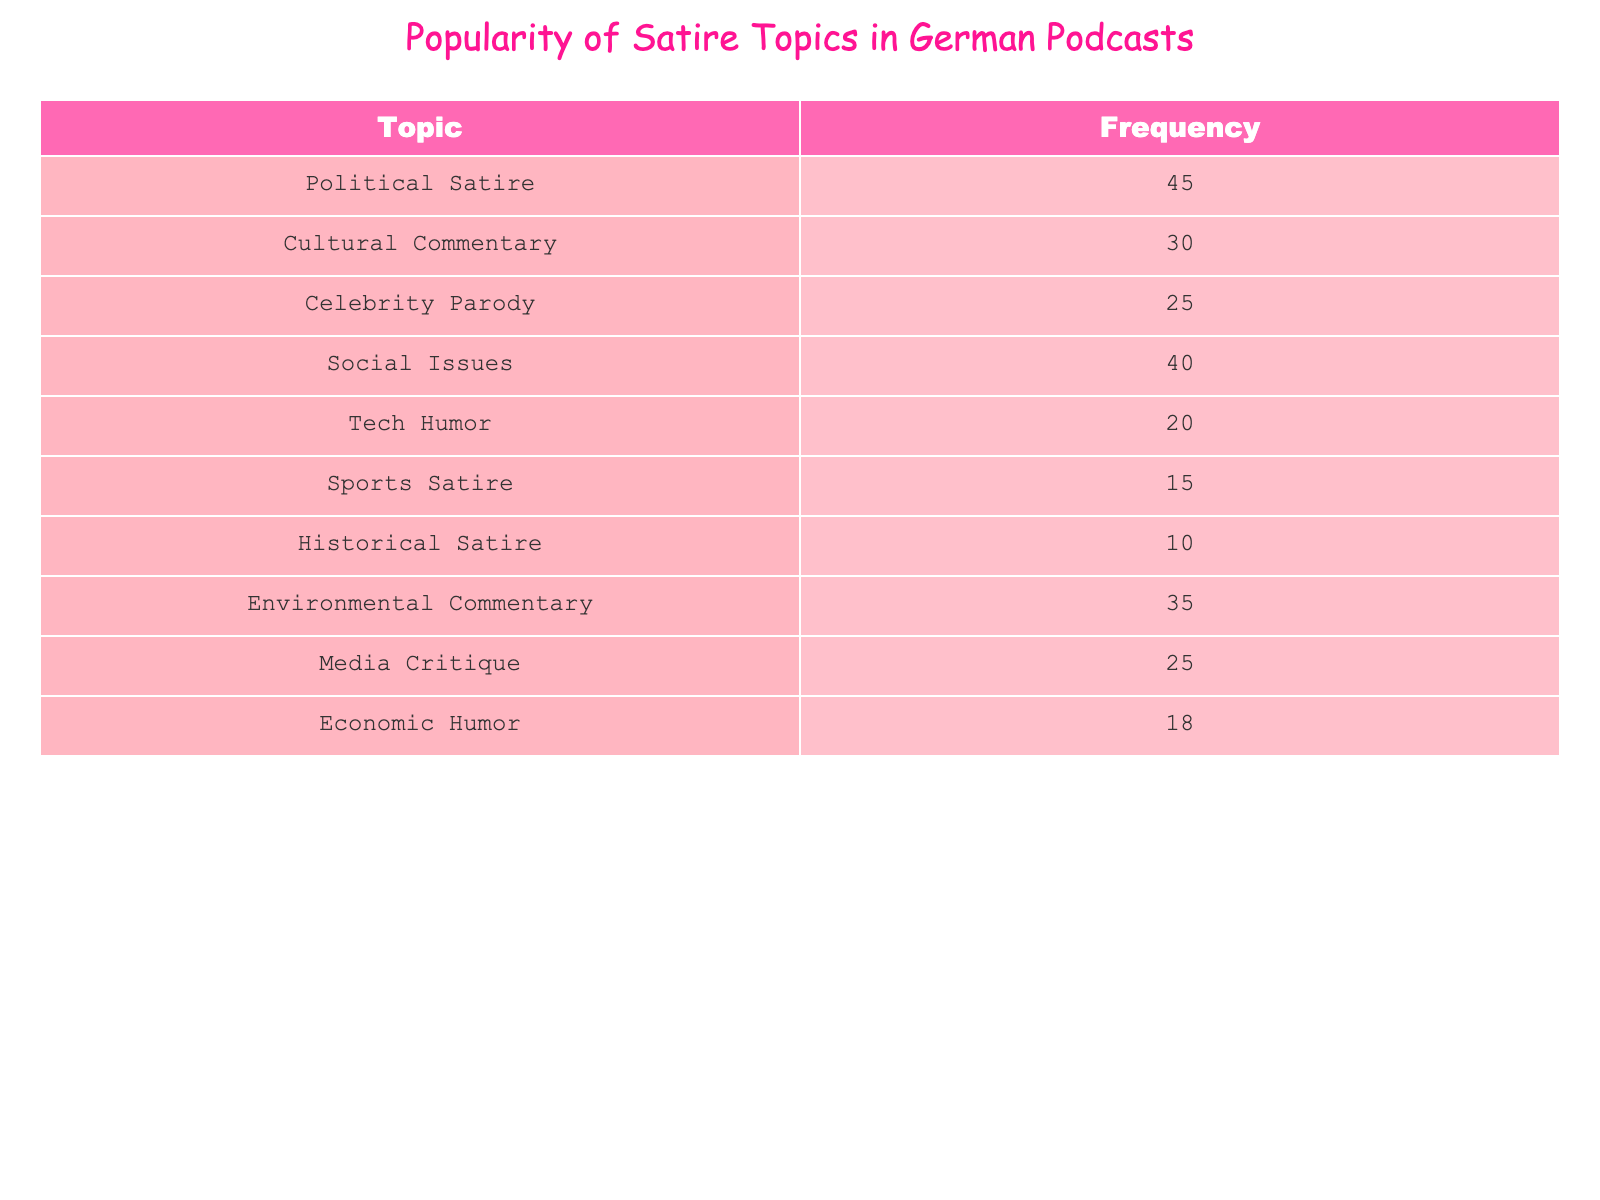What topic has the highest popularity in satire podcasts? By looking at the frequency values in the table, Political Satire has the highest frequency counting 45, which is more than any other topic listed.
Answer: Political Satire Which two topics have a combined frequency of 65? I need to find two topics whose frequencies add up to 65. By checking the values, Political Satire (45) and Environmental Commentary (35) combine to 80, but Social Issues (40) plus Celebrity Parody (25) gives 65.
Answer: Social Issues and Celebrity Parody Is Environmental Commentary more popular than Sports Satire? I will compare their frequencies: Environmental Commentary has a frequency of 35, while Sports Satire has a frequency of 15. Since 35 is greater than 15, it is true that Environmental Commentary is more popular.
Answer: Yes What is the average frequency of the topics listed? To find the average frequency, I first sum all the frequencies: 45 + 30 + 25 + 40 + 20 + 15 + 10 + 35 + 25 + 18 =  218. There are 10 topics, so the average is 218 divided by 10, which equals 21.8.
Answer: 21.8 How many topics have a frequency greater than 20? I will look at each frequency value and count how many are greater than 20. The relevant frequencies are 45, 30, 25, 40, and 35, making a total of 5 topics with a frequency greater than 20.
Answer: 5 What is the difference in frequency between the most and least popular topics? The most popular topic is Political Satire with a frequency of 45 and the least popular is Historical Satire with a frequency of 10. The difference is 45 minus 10, which equals 35.
Answer: 35 Which topic is equally popular as Celebrity Parody? I need to find a topic with a frequency of 25 since Celebrity Parody has that frequency. Upon checking the table, Media Critique also has a frequency of 25, confirming they are equally popular.
Answer: Media Critique True or False: Tech Humor is the least popular topic in the list. Tech Humor has a frequency of 20, and upon checking all topics, Historical Satire is the least popular with a frequency of 10, hence the statement is false.
Answer: False Which topic is more talked about: Social Issues or Economic Humor? I will compare the frequencies: Social Issues has a frequency of 40 while Economic Humor has a frequency of 18. Since 40 is greater than 18, Social Issues is indeed more talked about.
Answer: Social Issues 